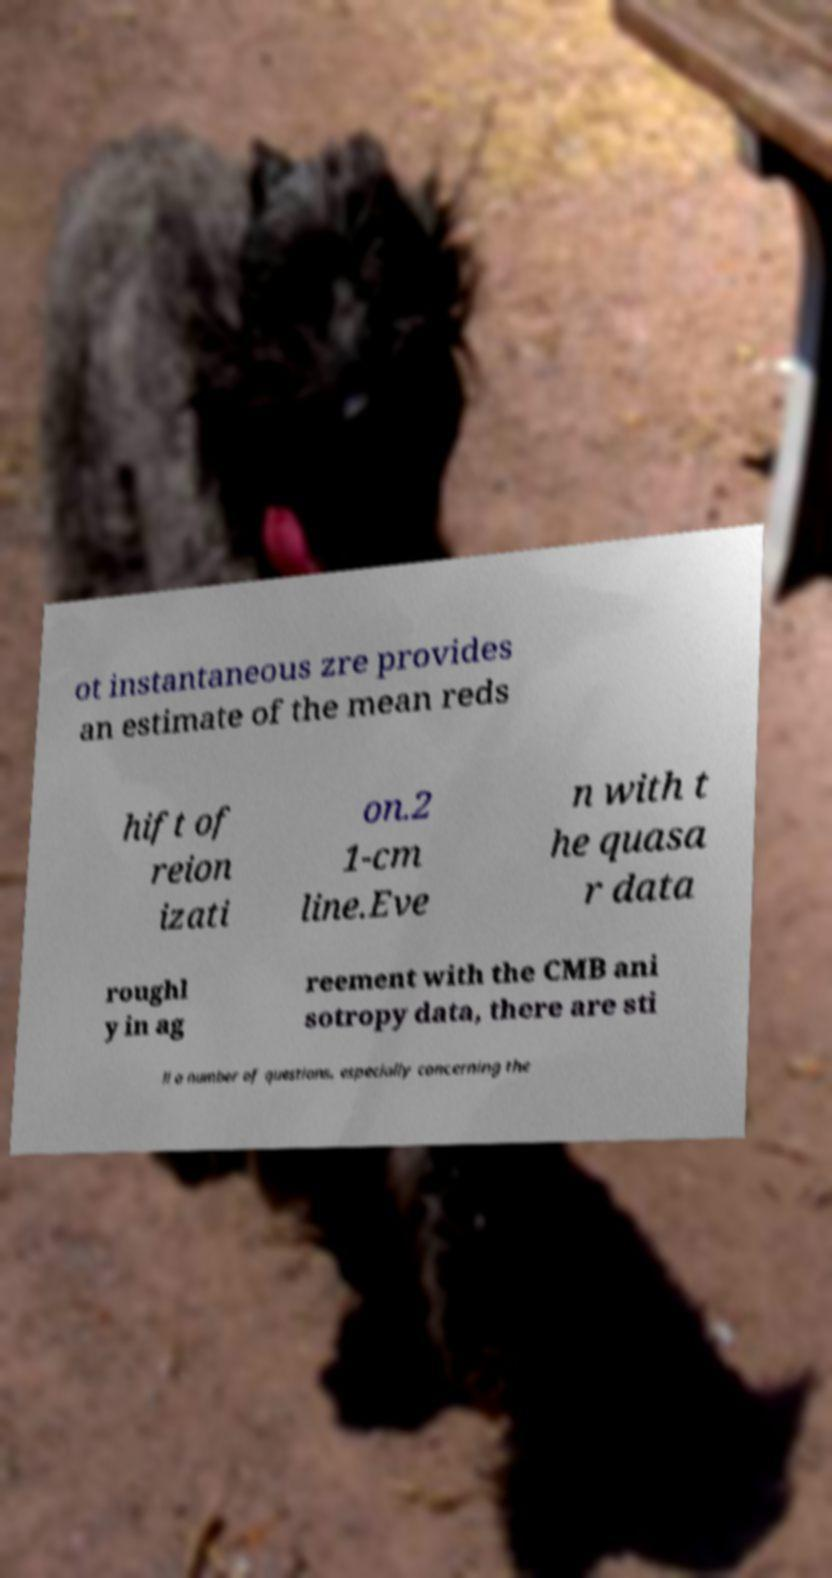Please identify and transcribe the text found in this image. ot instantaneous zre provides an estimate of the mean reds hift of reion izati on.2 1-cm line.Eve n with t he quasa r data roughl y in ag reement with the CMB ani sotropy data, there are sti ll a number of questions, especially concerning the 